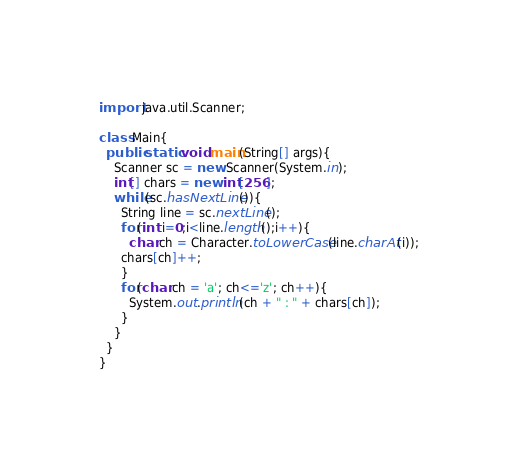Convert code to text. <code><loc_0><loc_0><loc_500><loc_500><_Java_>import java.util.Scanner;

class Main{
  public static void main(String[] args){
    Scanner sc = new Scanner(System.in);
    int[] chars = new int[256];
    while(sc.hasNextLine()){
      String line = sc.nextLine();
      for(int i=0;i<line.length();i++){
        char ch = Character.toLowerCase(line.charAt(i));
      chars[ch]++;
      }
      for(char ch = 'a'; ch<='z'; ch++){
        System.out.println(ch + " : " + chars[ch]);
      }
    }
  }
}</code> 